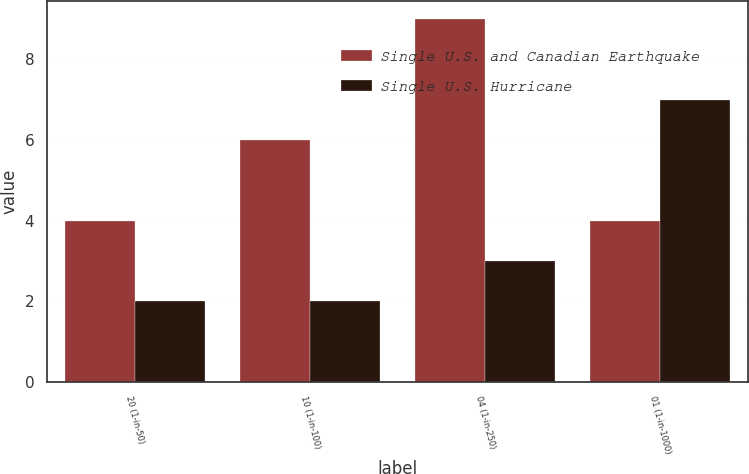<chart> <loc_0><loc_0><loc_500><loc_500><stacked_bar_chart><ecel><fcel>20 (1-in-50)<fcel>10 (1-in-100)<fcel>04 (1-in-250)<fcel>01 (1-in-1000)<nl><fcel>Single U.S. and Canadian Earthquake<fcel>4<fcel>6<fcel>9<fcel>4<nl><fcel>Single U.S. Hurricane<fcel>2<fcel>2<fcel>3<fcel>7<nl></chart> 